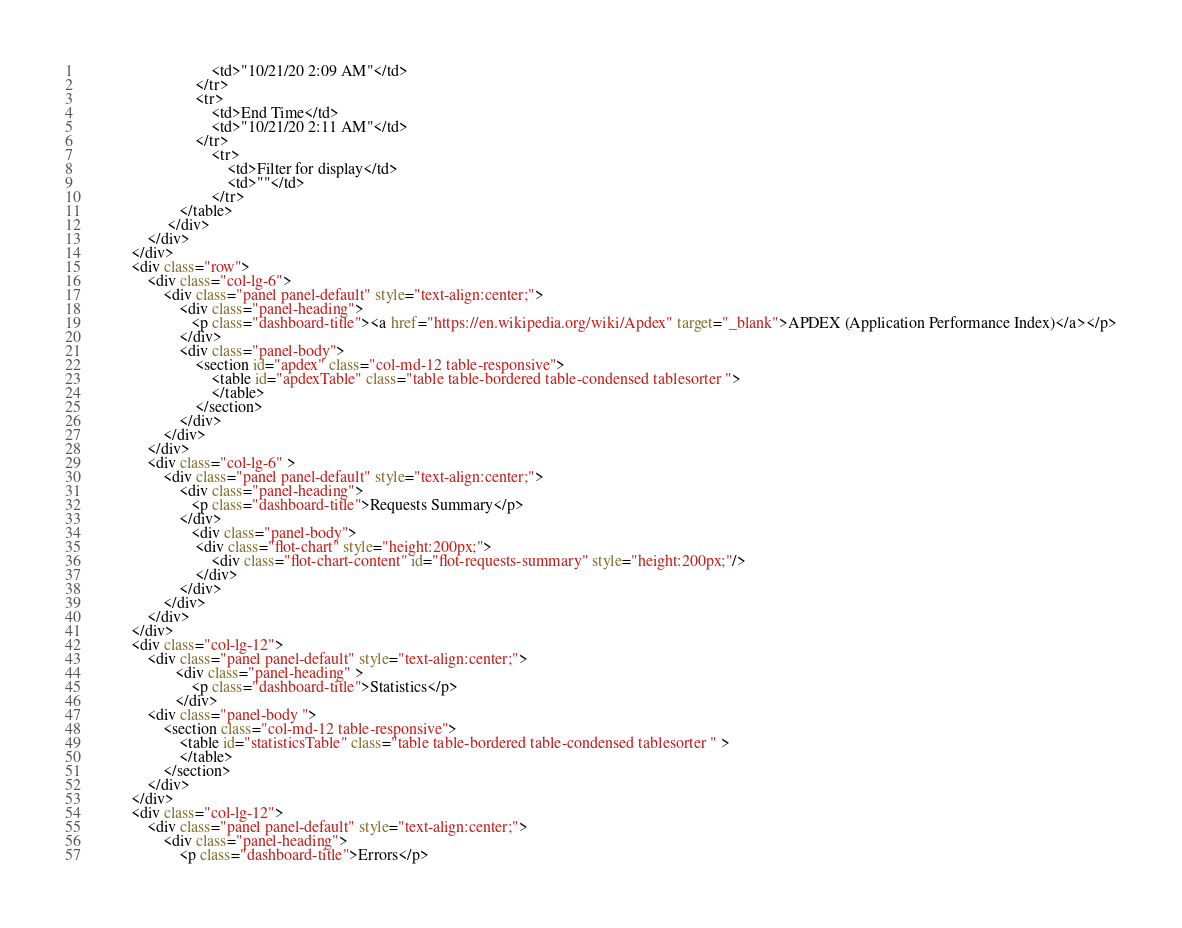Convert code to text. <code><loc_0><loc_0><loc_500><loc_500><_HTML_>                                <td>"10/21/20 2:09 AM"</td>
                            </tr>
                            <tr>
                                <td>End Time</td>
                                <td>"10/21/20 2:11 AM"</td>
                            </tr>
                                <tr>
                                    <td>Filter for display</td>
                                    <td>""</td>
                                </tr>
                        </table>
                     </div>
                </div>
            </div>
            <div class="row">
                <div class="col-lg-6">
                    <div class="panel panel-default" style="text-align:center;">
                        <div class="panel-heading">
                           <p class="dashboard-title"><a href="https://en.wikipedia.org/wiki/Apdex" target="_blank">APDEX (Application Performance Index)</a></p>
                        </div>
                        <div class="panel-body">
                            <section id="apdex" class="col-md-12 table-responsive">
                                <table id="apdexTable" class="table table-bordered table-condensed tablesorter ">
                                </table>
                            </section>
                        </div>
                    </div>
                </div>
                <div class="col-lg-6" >
                    <div class="panel panel-default" style="text-align:center;">
                        <div class="panel-heading">
                           <p class="dashboard-title">Requests Summary</p>
                        </div>
                           <div class="panel-body">
                            <div class="flot-chart" style="height:200px;">
                                <div class="flot-chart-content" id="flot-requests-summary" style="height:200px;"/>
                            </div>
                        </div>
                    </div>
                </div>
            </div>
            <div class="col-lg-12">
                <div class="panel panel-default" style="text-align:center;">
                       <div class="panel-heading" >
                           <p class="dashboard-title">Statistics</p>
                       </div>
                <div class="panel-body ">
                    <section class="col-md-12 table-responsive">
                        <table id="statisticsTable" class="table table-bordered table-condensed tablesorter " >
                        </table>
                    </section>
                </div>
            </div>
            <div class="col-lg-12">
                <div class="panel panel-default" style="text-align:center;">
                    <div class="panel-heading">
                        <p class="dashboard-title">Errors</p></code> 